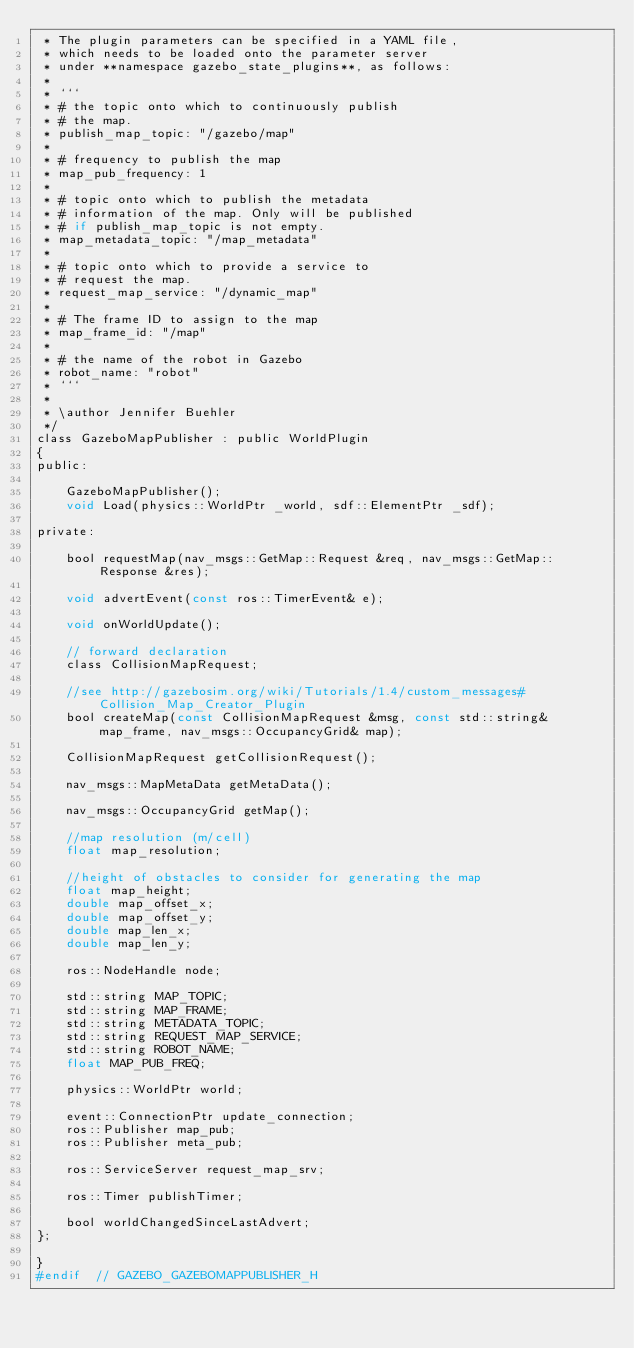Convert code to text. <code><loc_0><loc_0><loc_500><loc_500><_C_> * The plugin parameters can be specified in a YAML file,
 * which needs to be loaded onto the parameter server
 * under **namespace gazebo_state_plugins**, as follows:
 *
 * ```
 * # the topic onto which to continuously publish
 * # the map.
 * publish_map_topic: "/gazebo/map"
 * 
 * # frequency to publish the map
 * map_pub_frequency: 1
 * 
 * # topic onto which to publish the metadata
 * # information of the map. Only will be published
 * # if publish_map_topic is not empty.
 * map_metadata_topic: "/map_metadata"
 * 
 * # topic onto which to provide a service to
 * # request the map.
 * request_map_service: "/dynamic_map"
 * 
 * # The frame ID to assign to the map    
 * map_frame_id: "/map"
 * 
 * # the name of the robot in Gazebo
 * robot_name: "robot"
 * ```
 *
 * \author Jennifer Buehler
 */
class GazeboMapPublisher : public WorldPlugin
{
public: 

	GazeboMapPublisher();
  	void Load(physics::WorldPtr _world, sdf::ElementPtr _sdf);

private:

	bool requestMap(nav_msgs::GetMap::Request &req, nav_msgs::GetMap::Response &res); 

	void advertEvent(const ros::TimerEvent& e); 

	void onWorldUpdate(); 

    // forward declaration
    class CollisionMapRequest;

	//see http://gazebosim.org/wiki/Tutorials/1.4/custom_messages#Collision_Map_Creator_Plugin
	bool createMap(const CollisionMapRequest &msg, const std::string& map_frame, nav_msgs::OccupancyGrid& map);

	CollisionMapRequest getCollisionRequest();

	nav_msgs::MapMetaData getMetaData(); 

	nav_msgs::OccupancyGrid getMap(); 
	
    //map resolution (m/cell)
	float map_resolution;

    //height of obstacles to consider for generating the map
	float map_height;
	double map_offset_x;
	double map_offset_y;
	double map_len_x;
	double map_len_y;

    ros::NodeHandle node;

	std::string MAP_TOPIC;
	std::string MAP_FRAME;
	std::string METADATA_TOPIC;
	std::string REQUEST_MAP_SERVICE;
	std::string ROBOT_NAME;
	float MAP_PUB_FREQ;
	
	physics::WorldPtr world;

	event::ConnectionPtr update_connection;
	ros::Publisher map_pub;
	ros::Publisher meta_pub;

	ros::ServiceServer request_map_srv;
		
	ros::Timer publishTimer;

	bool worldChangedSinceLastAdvert; 
};

}
#endif  // GAZEBO_GAZEBOMAPPUBLISHER_H
</code> 